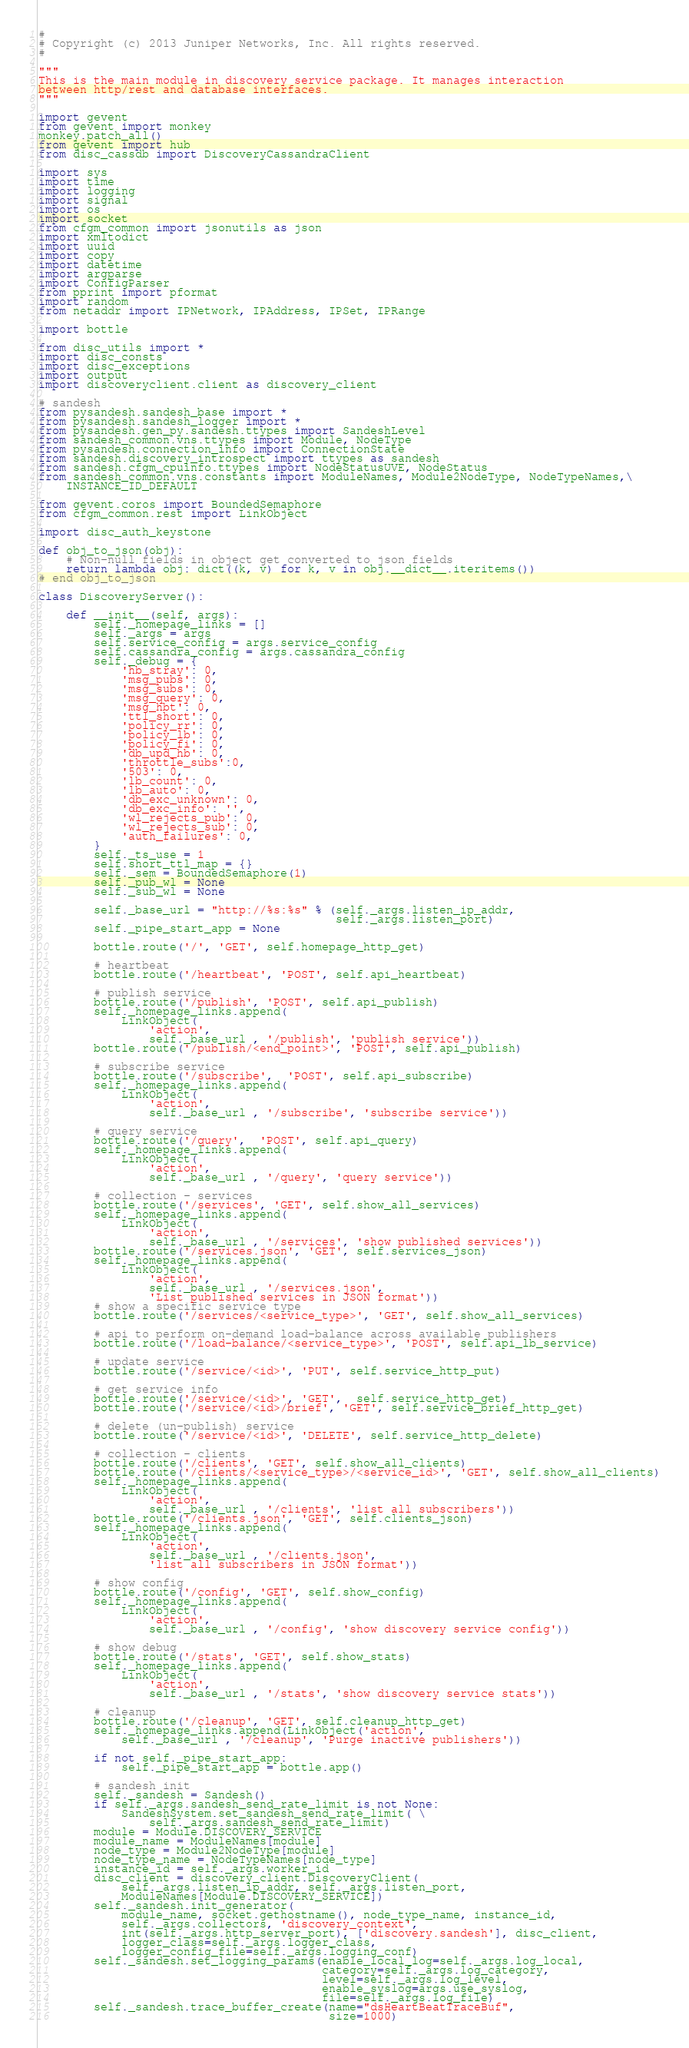<code> <loc_0><loc_0><loc_500><loc_500><_Python_>#
# Copyright (c) 2013 Juniper Networks, Inc. All rights reserved.
#

"""
This is the main module in discovery service package. It manages interaction
between http/rest and database interfaces.
"""

import gevent
from gevent import monkey
monkey.patch_all()
from gevent import hub
from disc_cassdb import DiscoveryCassandraClient

import sys
import time
import logging
import signal
import os
import socket
from cfgm_common import jsonutils as json
import xmltodict
import uuid
import copy
import datetime
import argparse
import ConfigParser
from pprint import pformat
import random
from netaddr import IPNetwork, IPAddress, IPSet, IPRange

import bottle

from disc_utils import *
import disc_consts
import disc_exceptions
import output
import discoveryclient.client as discovery_client

# sandesh
from pysandesh.sandesh_base import *
from pysandesh.sandesh_logger import *
from pysandesh.gen_py.sandesh.ttypes import SandeshLevel
from sandesh_common.vns.ttypes import Module, NodeType
from pysandesh.connection_info import ConnectionState
from sandesh.discovery_introspect import ttypes as sandesh
from sandesh.cfgm_cpuinfo.ttypes import NodeStatusUVE, NodeStatus
from sandesh_common.vns.constants import ModuleNames, Module2NodeType, NodeTypeNames,\
    INSTANCE_ID_DEFAULT

from gevent.coros import BoundedSemaphore
from cfgm_common.rest import LinkObject

import disc_auth_keystone

def obj_to_json(obj):
    # Non-null fields in object get converted to json fields
    return lambda obj: dict((k, v) for k, v in obj.__dict__.iteritems())
# end obj_to_json

class DiscoveryServer():

    def __init__(self, args):
        self._homepage_links = []
        self._args = args
        self.service_config = args.service_config
        self.cassandra_config = args.cassandra_config
        self._debug = {
            'hb_stray': 0,
            'msg_pubs': 0,
            'msg_subs': 0,
            'msg_query': 0,
            'msg_hbt': 0,
            'ttl_short': 0,
            'policy_rr': 0,
            'policy_lb': 0,
            'policy_fi': 0,
            'db_upd_hb': 0,
            'throttle_subs':0,
            '503': 0,
            'lb_count': 0,
            'lb_auto': 0,
            'db_exc_unknown': 0,
            'db_exc_info': '',
            'wl_rejects_pub': 0,
            'wl_rejects_sub': 0,
            'auth_failures': 0,
        }
        self._ts_use = 1
        self.short_ttl_map = {}
        self._sem = BoundedSemaphore(1)
        self._pub_wl = None
        self._sub_wl = None

        self._base_url = "http://%s:%s" % (self._args.listen_ip_addr,
                                           self._args.listen_port)
        self._pipe_start_app = None

        bottle.route('/', 'GET', self.homepage_http_get)

        # heartbeat
        bottle.route('/heartbeat', 'POST', self.api_heartbeat)

        # publish service
        bottle.route('/publish', 'POST', self.api_publish)
        self._homepage_links.append(
            LinkObject(
                'action',
                self._base_url , '/publish', 'publish service'))
        bottle.route('/publish/<end_point>', 'POST', self.api_publish)

        # subscribe service
        bottle.route('/subscribe',  'POST', self.api_subscribe)
        self._homepage_links.append(
            LinkObject(
                'action',
                self._base_url , '/subscribe', 'subscribe service'))

        # query service
        bottle.route('/query',  'POST', self.api_query)
        self._homepage_links.append(
            LinkObject(
                'action',
                self._base_url , '/query', 'query service'))

        # collection - services
        bottle.route('/services', 'GET', self.show_all_services)
        self._homepage_links.append(
            LinkObject(
                'action',
                self._base_url , '/services', 'show published services'))
        bottle.route('/services.json', 'GET', self.services_json)
        self._homepage_links.append(
            LinkObject(
                'action',
                self._base_url , '/services.json',
                'List published services in JSON format'))
        # show a specific service type
        bottle.route('/services/<service_type>', 'GET', self.show_all_services)

        # api to perform on-demand load-balance across available publishers
        bottle.route('/load-balance/<service_type>', 'POST', self.api_lb_service)

        # update service
        bottle.route('/service/<id>', 'PUT', self.service_http_put)

        # get service info
        bottle.route('/service/<id>', 'GET',  self.service_http_get)
        bottle.route('/service/<id>/brief', 'GET', self.service_brief_http_get)

        # delete (un-publish) service
        bottle.route('/service/<id>', 'DELETE', self.service_http_delete)

        # collection - clients
        bottle.route('/clients', 'GET', self.show_all_clients)
        bottle.route('/clients/<service_type>/<service_id>', 'GET', self.show_all_clients)
        self._homepage_links.append(
            LinkObject(
                'action',
                self._base_url , '/clients', 'list all subscribers'))
        bottle.route('/clients.json', 'GET', self.clients_json)
        self._homepage_links.append(
            LinkObject(
                'action',
                self._base_url , '/clients.json',
                'list all subscribers in JSON format'))

        # show config
        bottle.route('/config', 'GET', self.show_config)
        self._homepage_links.append(
            LinkObject(
                'action',
                self._base_url , '/config', 'show discovery service config'))

        # show debug
        bottle.route('/stats', 'GET', self.show_stats)
        self._homepage_links.append(
            LinkObject(
                'action',
                self._base_url , '/stats', 'show discovery service stats'))

        # cleanup
        bottle.route('/cleanup', 'GET', self.cleanup_http_get)
        self._homepage_links.append(LinkObject('action',
            self._base_url , '/cleanup', 'Purge inactive publishers'))

        if not self._pipe_start_app:
            self._pipe_start_app = bottle.app()

        # sandesh init
        self._sandesh = Sandesh()
        if self._args.sandesh_send_rate_limit is not None:
            SandeshSystem.set_sandesh_send_rate_limit( \
                self._args.sandesh_send_rate_limit)
        module = Module.DISCOVERY_SERVICE
        module_name = ModuleNames[module]
        node_type = Module2NodeType[module]
        node_type_name = NodeTypeNames[node_type]
        instance_id = self._args.worker_id
        disc_client = discovery_client.DiscoveryClient(
            self._args.listen_ip_addr, self._args.listen_port,
            ModuleNames[Module.DISCOVERY_SERVICE])
        self._sandesh.init_generator(
            module_name, socket.gethostname(), node_type_name, instance_id,
            self._args.collectors, 'discovery_context',
            int(self._args.http_server_port), ['discovery.sandesh'], disc_client,
            logger_class=self._args.logger_class,
            logger_config_file=self._args.logging_conf)
        self._sandesh.set_logging_params(enable_local_log=self._args.log_local,
                                         category=self._args.log_category,
                                         level=self._args.log_level,
                                         enable_syslog=args.use_syslog,
                                         file=self._args.log_file)
        self._sandesh.trace_buffer_create(name="dsHeartBeatTraceBuf",
                                          size=1000)</code> 